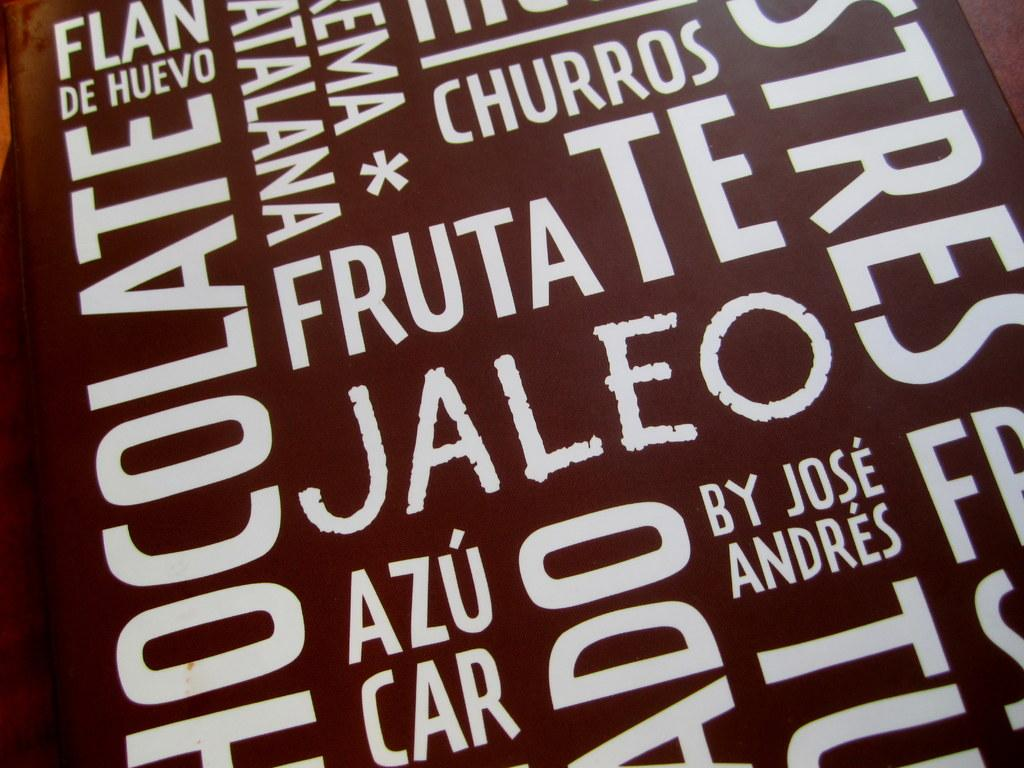<image>
Render a clear and concise summary of the photo. brown background with white colored words such as fruta, churros, jaleoin in different directions 